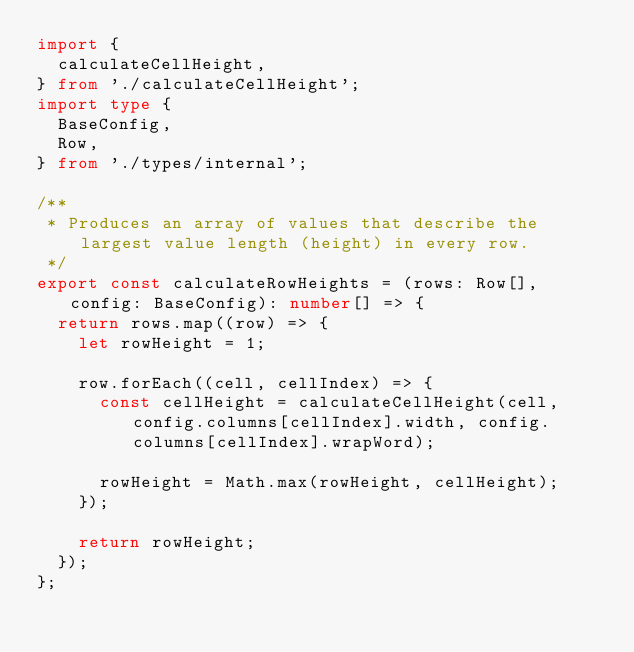Convert code to text. <code><loc_0><loc_0><loc_500><loc_500><_TypeScript_>import {
  calculateCellHeight,
} from './calculateCellHeight';
import type {
  BaseConfig,
  Row,
} from './types/internal';

/**
 * Produces an array of values that describe the largest value length (height) in every row.
 */
export const calculateRowHeights = (rows: Row[], config: BaseConfig): number[] => {
  return rows.map((row) => {
    let rowHeight = 1;

    row.forEach((cell, cellIndex) => {
      const cellHeight = calculateCellHeight(cell, config.columns[cellIndex].width, config.columns[cellIndex].wrapWord);

      rowHeight = Math.max(rowHeight, cellHeight);
    });

    return rowHeight;
  });
};
</code> 